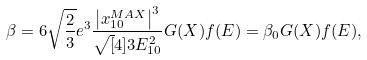<formula> <loc_0><loc_0><loc_500><loc_500>\beta = 6 \sqrt { \frac { 2 } { 3 } } e ^ { 3 } \frac { \left | x _ { 1 0 } ^ { M A X } \right | ^ { 3 } } { \sqrt { [ } 4 ] { 3 } E _ { 1 0 } ^ { 2 } } G ( X ) f ( E ) = \beta _ { 0 } G ( X ) f ( E ) ,</formula> 